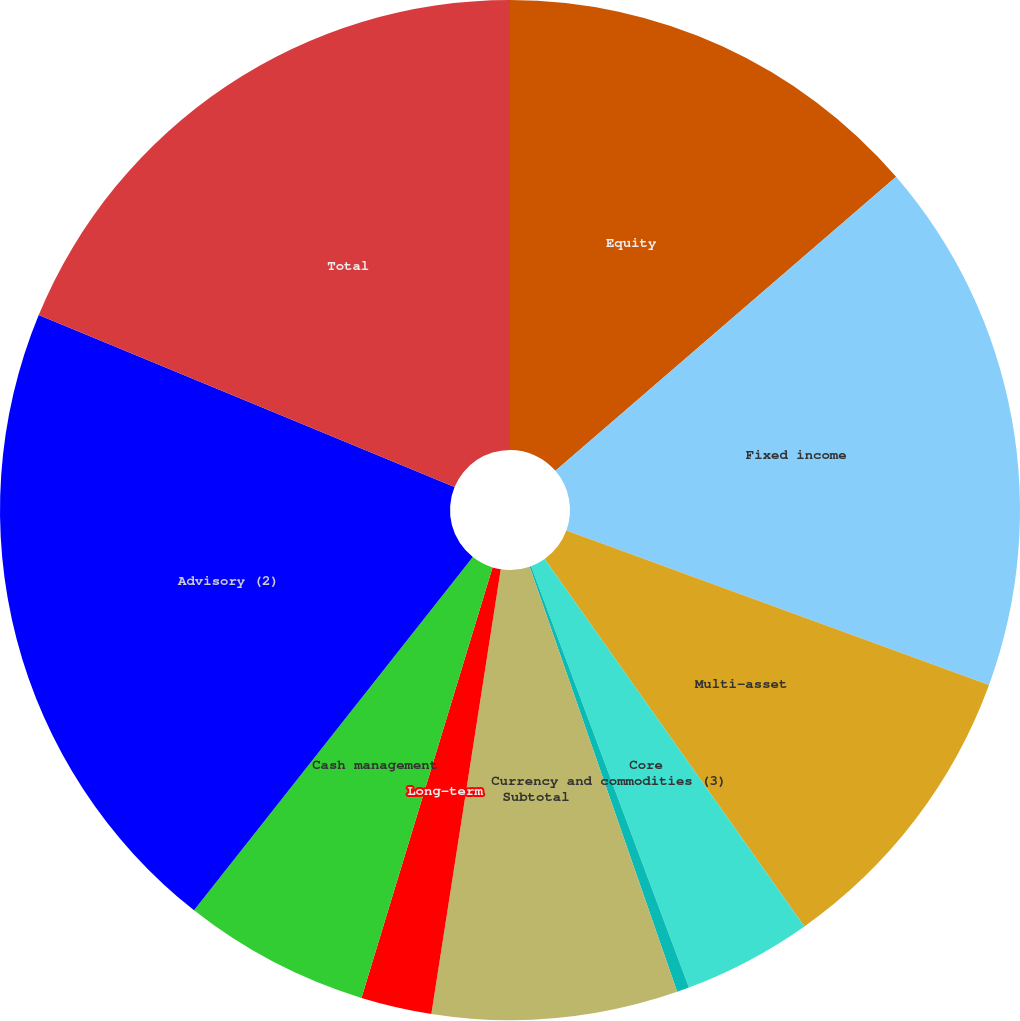Convert chart. <chart><loc_0><loc_0><loc_500><loc_500><pie_chart><fcel>Equity<fcel>Fixed income<fcel>Multi-asset<fcel>Core<fcel>Currency and commodities (3)<fcel>Subtotal<fcel>Long-term<fcel>Cash management<fcel>Advisory (2)<fcel>Total<nl><fcel>13.67%<fcel>16.91%<fcel>9.63%<fcel>4.09%<fcel>0.39%<fcel>7.78%<fcel>2.24%<fcel>5.93%<fcel>20.61%<fcel>18.76%<nl></chart> 